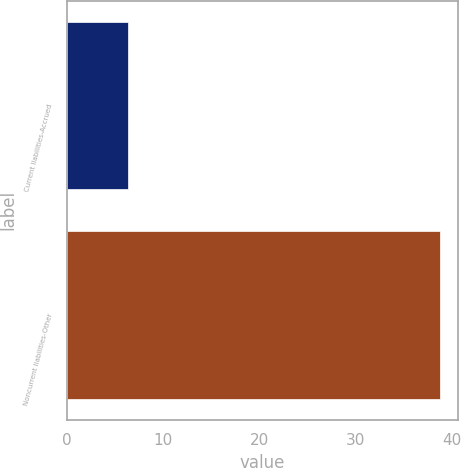Convert chart to OTSL. <chart><loc_0><loc_0><loc_500><loc_500><bar_chart><fcel>Current liabilities-Accrued<fcel>Noncurrent liabilities-Other<nl><fcel>6.3<fcel>38.7<nl></chart> 